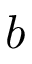<formula> <loc_0><loc_0><loc_500><loc_500>b</formula> 